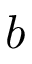<formula> <loc_0><loc_0><loc_500><loc_500>b</formula> 